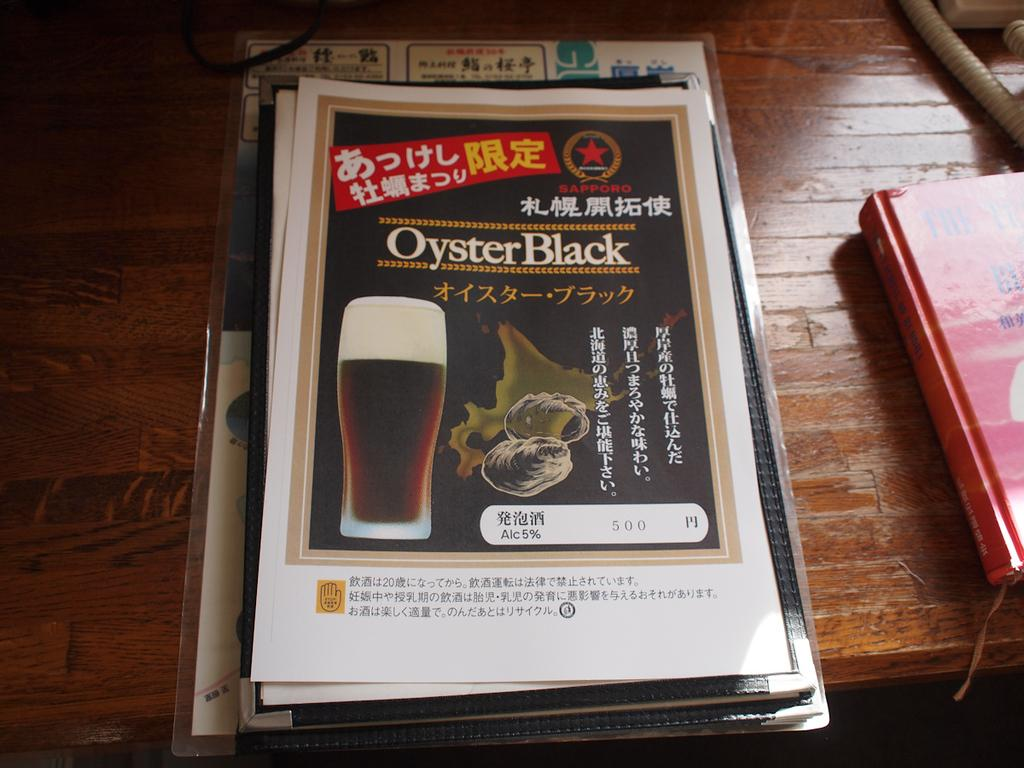<image>
Describe the image concisely. A flyer with Chinese letters at the top advertising Oyster Black. 